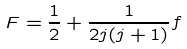<formula> <loc_0><loc_0><loc_500><loc_500>F = \frac { 1 } { 2 } + \frac { 1 } { 2 j ( j + 1 ) } f</formula> 